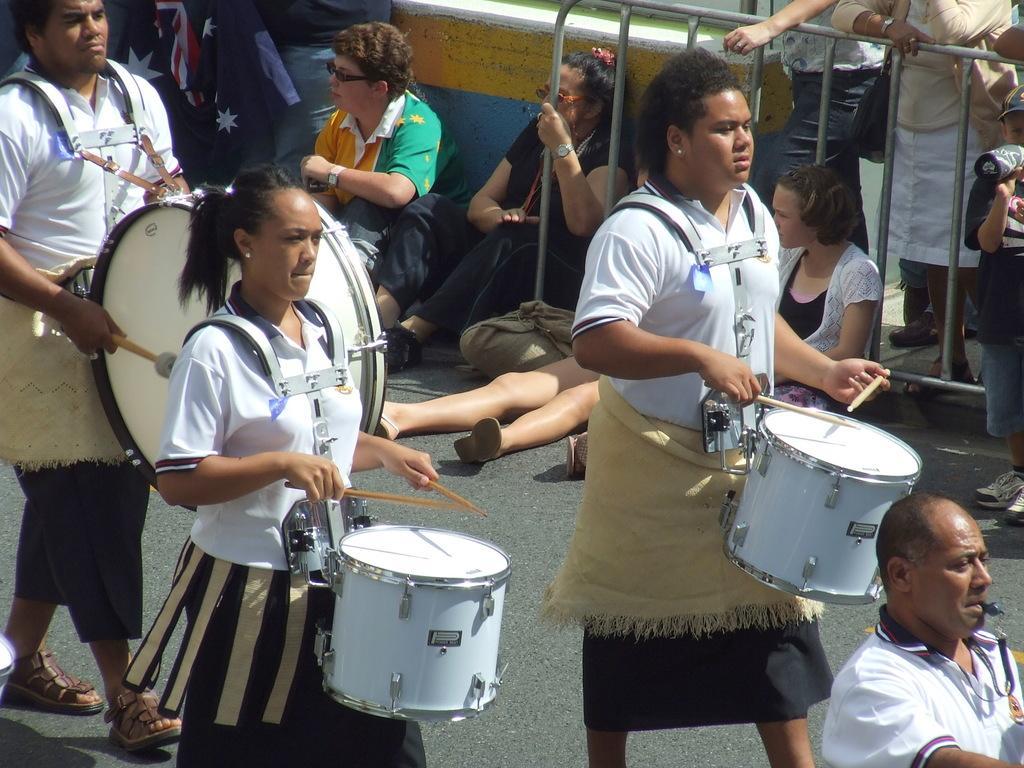How would you summarize this image in a sentence or two? This image is taken in outdoors. There are many people in this image. In the left side of the image a man is walking on the road holding a drums in his hands. In the middle of the image a woman is playing a drums. In the right side of the image a woman is walking on the road. At the background there are few people sitting on the road, there is a railing and a flag. 